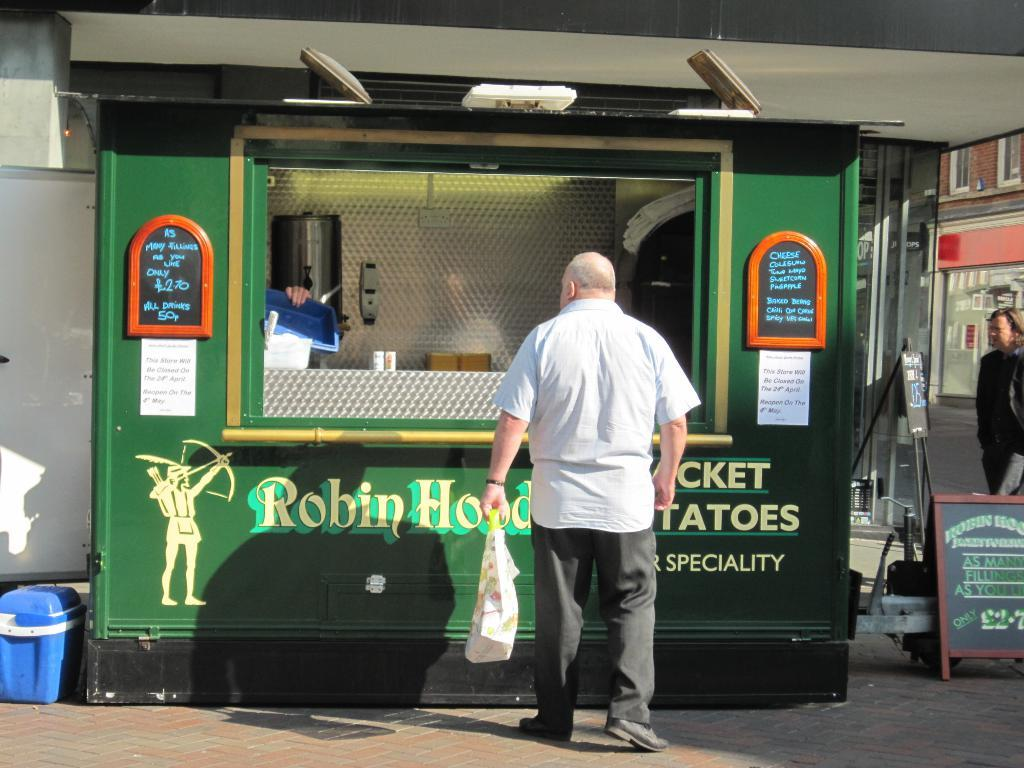How many people are present in the image? There are two persons standing in the image. What objects can be seen in the image besides the people? There are boards, papers, and other objects in the image. What can be seen in the background of the image? There is a shop and a building in the background of the image. What type of metal is being used to make the head in the image? There is no head present in the image, so it is not possible to determine what type of metal might be used. 